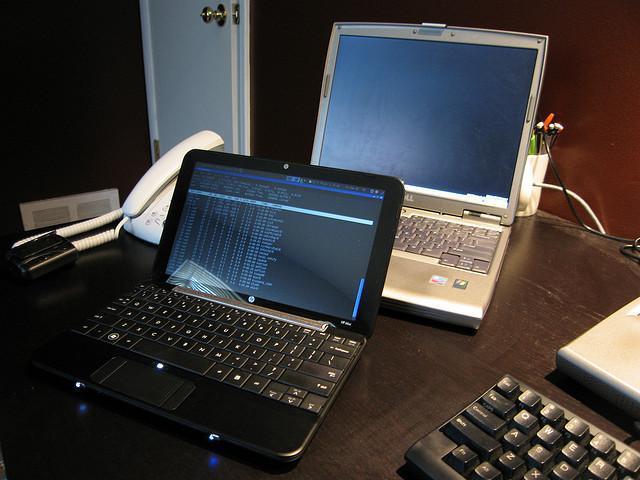How many keyboards are in the picture?
Give a very brief answer. 3. How many keyboards are there?
Give a very brief answer. 3. How many laptops are in the photo?
Give a very brief answer. 2. How many birds are there?
Give a very brief answer. 0. 